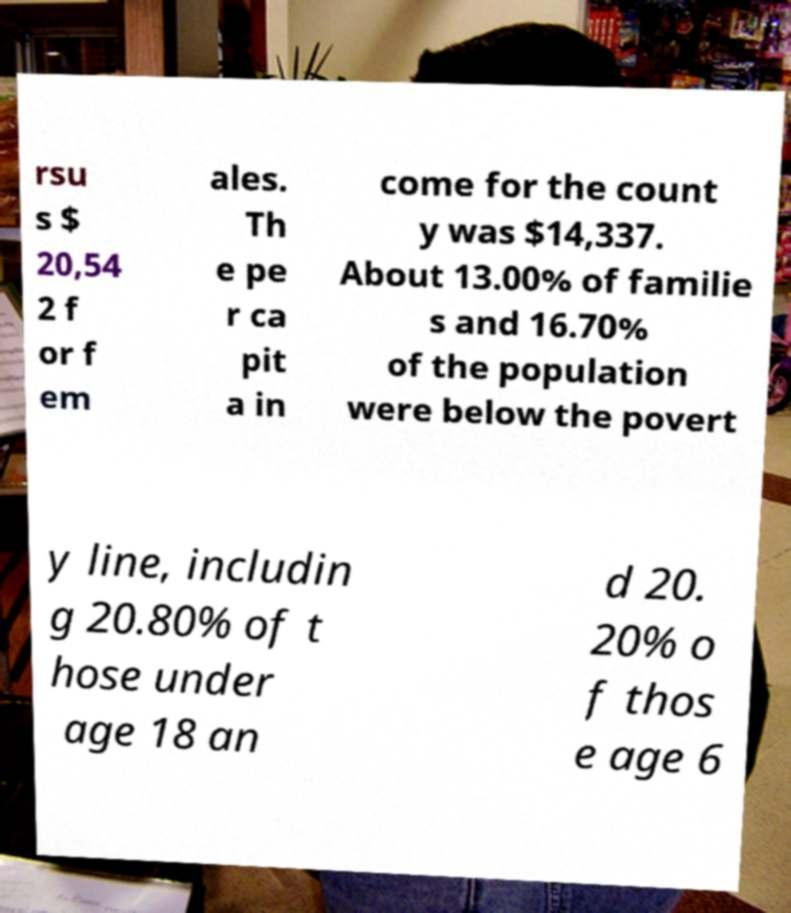Could you assist in decoding the text presented in this image and type it out clearly? rsu s $ 20,54 2 f or f em ales. Th e pe r ca pit a in come for the count y was $14,337. About 13.00% of familie s and 16.70% of the population were below the povert y line, includin g 20.80% of t hose under age 18 an d 20. 20% o f thos e age 6 